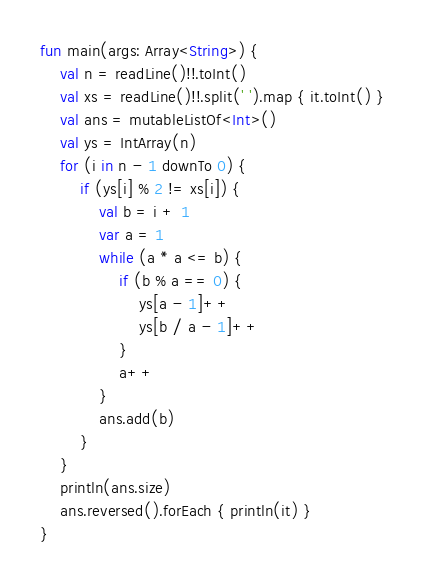Convert code to text. <code><loc_0><loc_0><loc_500><loc_500><_Kotlin_>fun main(args: Array<String>) {
    val n = readLine()!!.toInt()
    val xs = readLine()!!.split(' ').map { it.toInt() }
    val ans = mutableListOf<Int>()
    val ys = IntArray(n)
    for (i in n - 1 downTo 0) {
        if (ys[i] % 2 != xs[i]) {
            val b = i + 1
            var a = 1
            while (a * a <= b) {
                if (b % a == 0) {
                    ys[a - 1]++
                    ys[b / a - 1]++
                }
                a++
            }
            ans.add(b)
        }
    }
    println(ans.size)
    ans.reversed().forEach { println(it) }
}
</code> 